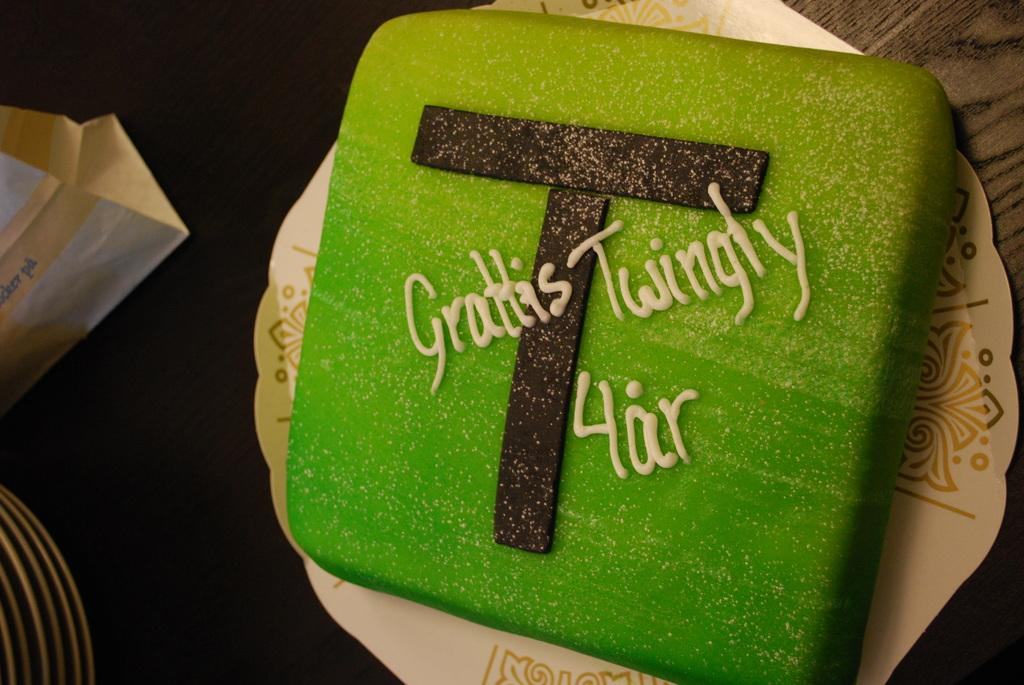What type of cake is on the paper plate in the image? There is a green color cake on a paper plate in the image. What is the surface beneath the cake? There is a table at the bottom of the image. What can be seen on the left side of the image? There are objects to the left side of the image. What title is written on the cake in the image? There is no title written on the cake in the image. What type of liquid is contained in the box on the left side of the image? There is no box or liquid present in the image. 